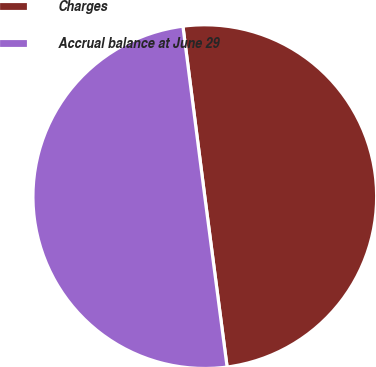<chart> <loc_0><loc_0><loc_500><loc_500><pie_chart><fcel>Charges<fcel>Accrual balance at June 29<nl><fcel>49.96%<fcel>50.04%<nl></chart> 